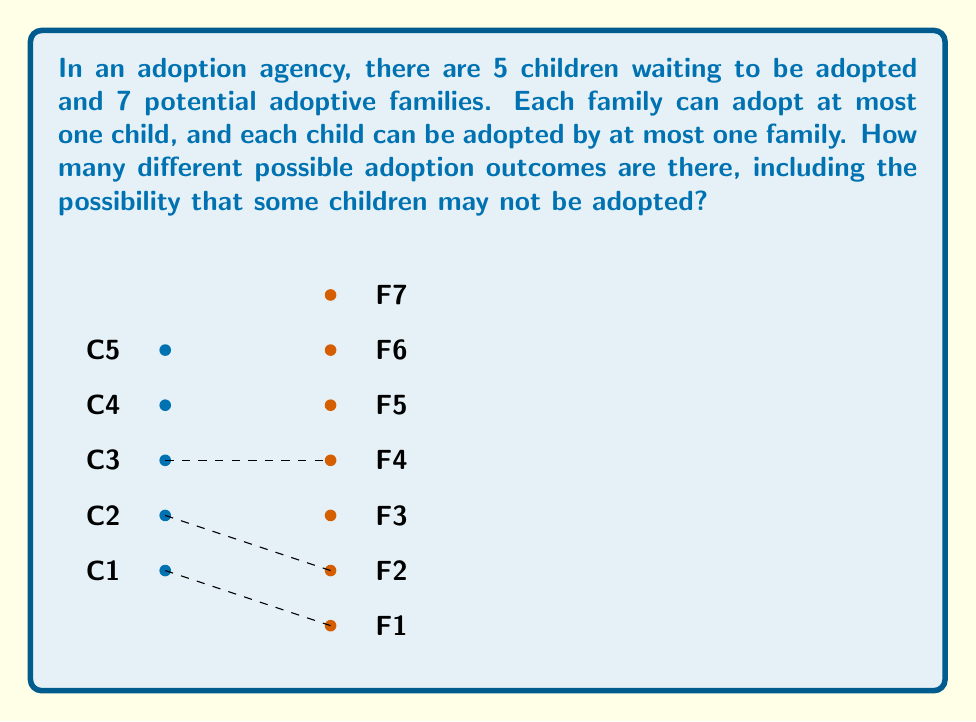What is the answer to this math problem? Let's approach this step-by-step:

1) First, we need to understand that this is a matching problem, where we're counting the number of ways to match children to families, including the option of not matching some children.

2) We can think of this as assigning each child to either one of the 7 families or to no family at all. This gives us 8 options for each child (7 families + 1 no family option).

3) Since each child's assignment is independent of the others, and we have 5 children, we can use the multiplication principle.

4) The total number of possibilities is therefore:

   $$8^5$$

5) Let's break this down:
   - For the first child, we have 8 choices
   - For the second child, we again have 8 choices, regardless of what we chose for the first child
   - This continues for all 5 children

6) Calculating:

   $$8^5 = 8 \times 8 \times 8 \times 8 \times 8 = 32,768$$

7) Note: This method counts all possible assignments, including those where a family might be assigned to multiple children. However, the question states that each family can adopt at most one child. Our count is still correct because in the cases where a family is "assigned" to multiple children in our counting, all but one of those assignments would be to the "no family" option in reality.
Answer: 32,768 